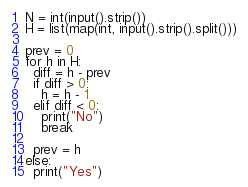<code> <loc_0><loc_0><loc_500><loc_500><_Python_>N = int(input().strip())
H = list(map(int, input().strip().split()))

prev = 0
for h in H:
  diff = h - prev
  if diff > 0:
    h = h - 1
  elif diff < 0:
    print("No")
    break

  prev = h
else:
  print("Yes")</code> 